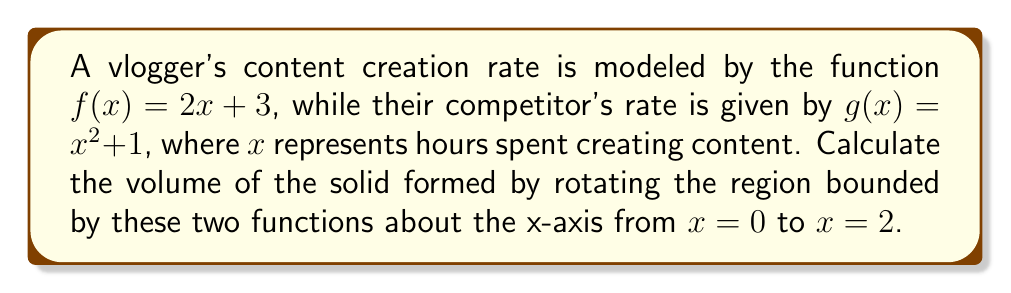Give your solution to this math problem. To solve this problem, we'll use the washer method for calculating the volume of a solid of revolution:

1) First, identify the upper and lower functions:
   Upper function: $f(x) = 2x + 3$
   Lower function: $g(x) = x^2 + 1$

2) The volume formula using the washer method is:
   $$V = \pi \int_a^b [(R(x))^2 - (r(x))^2] dx$$
   where $R(x)$ is the outer radius and $r(x)$ is the inner radius.

3) In this case:
   $R(x) = f(x) = 2x + 3$
   $r(x) = g(x) = x^2 + 1$
   $a = 0$ and $b = 2$

4) Substituting into the formula:
   $$V = \pi \int_0^2 [(2x + 3)^2 - (x^2 + 1)^2] dx$$

5) Expand the integrand:
   $$V = \pi \int_0^2 [(4x^2 + 12x + 9) - (x^4 + 2x^2 + 1)] dx$$
   $$V = \pi \int_0^2 [-x^4 + 2x^2 + 12x + 8] dx$$

6) Integrate:
   $$V = \pi [-\frac{1}{5}x^5 + \frac{2}{3}x^3 + 6x^2 + 8x]_0^2$$

7) Evaluate the definite integral:
   $$V = \pi [(-\frac{32}{5} + \frac{16}{3} + 24 + 16) - (0)]$$
   $$V = \pi [\frac{-96 + 80 + 360 + 240}{15}]$$
   $$V = \pi [\frac{584}{15}]$$

8) Simplify:
   $$V = \frac{584\pi}{15}$$
Answer: $\frac{584\pi}{15}$ cubic units 